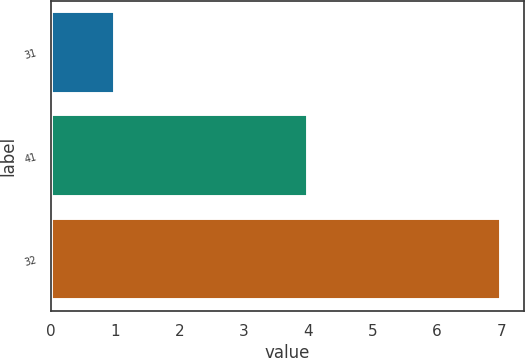Convert chart. <chart><loc_0><loc_0><loc_500><loc_500><bar_chart><fcel>31<fcel>41<fcel>32<nl><fcel>1<fcel>4<fcel>7<nl></chart> 